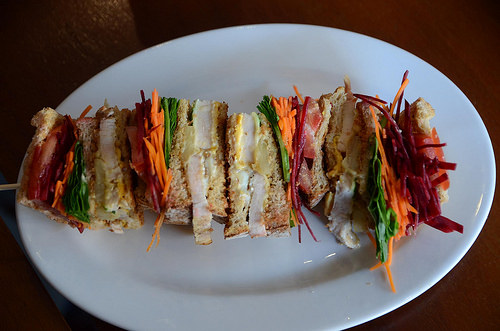<image>
Is there a kabob next to the plate? No. The kabob is not positioned next to the plate. They are located in different areas of the scene. 